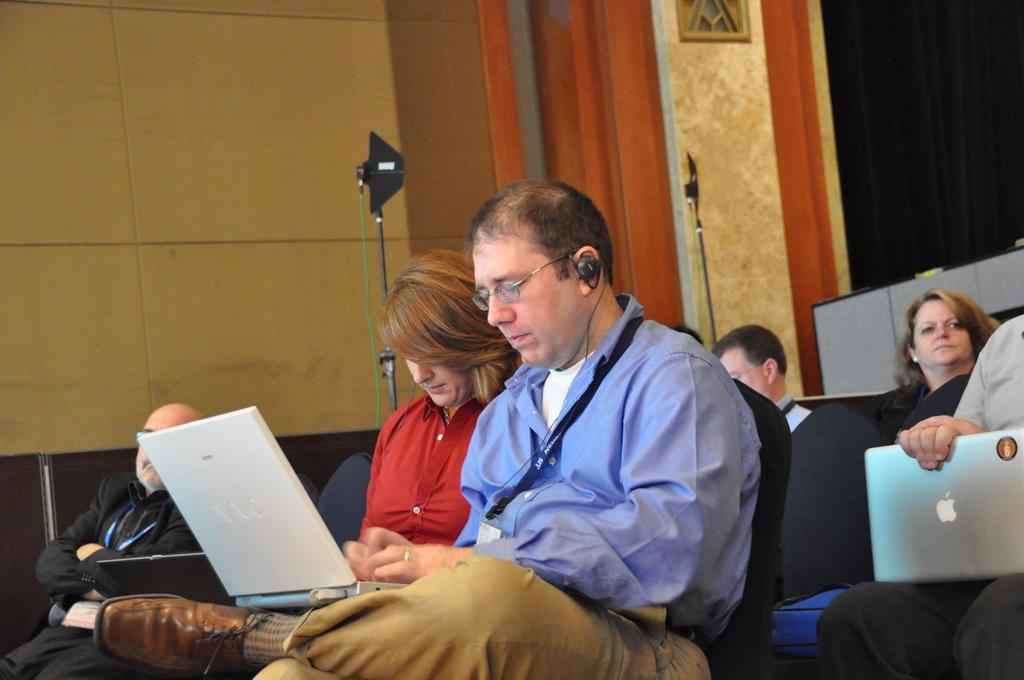Please provide a concise description of this image. This is an inside view of a room. Here I can see few people are sitting on the chairs. In the foreground two persons are holding laptops in their hands. In the background, I can see two metal stands and a wall. On the right side, I can see a black color curtain. 